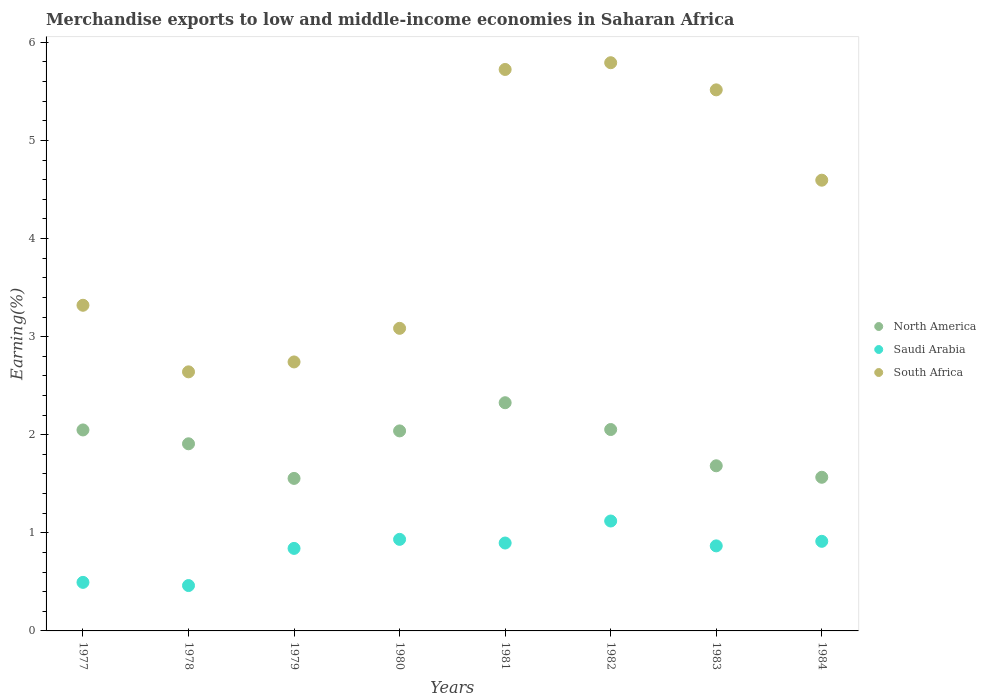How many different coloured dotlines are there?
Your answer should be compact. 3. What is the percentage of amount earned from merchandise exports in North America in 1980?
Give a very brief answer. 2.04. Across all years, what is the maximum percentage of amount earned from merchandise exports in South Africa?
Provide a succinct answer. 5.79. Across all years, what is the minimum percentage of amount earned from merchandise exports in Saudi Arabia?
Provide a succinct answer. 0.46. In which year was the percentage of amount earned from merchandise exports in Saudi Arabia maximum?
Give a very brief answer. 1982. In which year was the percentage of amount earned from merchandise exports in Saudi Arabia minimum?
Provide a succinct answer. 1978. What is the total percentage of amount earned from merchandise exports in South Africa in the graph?
Offer a terse response. 33.41. What is the difference between the percentage of amount earned from merchandise exports in South Africa in 1983 and that in 1984?
Provide a succinct answer. 0.92. What is the difference between the percentage of amount earned from merchandise exports in North America in 1981 and the percentage of amount earned from merchandise exports in South Africa in 1982?
Give a very brief answer. -3.47. What is the average percentage of amount earned from merchandise exports in South Africa per year?
Your response must be concise. 4.18. In the year 1978, what is the difference between the percentage of amount earned from merchandise exports in Saudi Arabia and percentage of amount earned from merchandise exports in North America?
Ensure brevity in your answer.  -1.45. What is the ratio of the percentage of amount earned from merchandise exports in South Africa in 1978 to that in 1981?
Offer a terse response. 0.46. Is the percentage of amount earned from merchandise exports in Saudi Arabia in 1982 less than that in 1983?
Your answer should be very brief. No. What is the difference between the highest and the second highest percentage of amount earned from merchandise exports in Saudi Arabia?
Your response must be concise. 0.19. What is the difference between the highest and the lowest percentage of amount earned from merchandise exports in North America?
Provide a short and direct response. 0.77. In how many years, is the percentage of amount earned from merchandise exports in South Africa greater than the average percentage of amount earned from merchandise exports in South Africa taken over all years?
Your answer should be very brief. 4. Is the percentage of amount earned from merchandise exports in South Africa strictly greater than the percentage of amount earned from merchandise exports in North America over the years?
Offer a terse response. Yes. Is the percentage of amount earned from merchandise exports in Saudi Arabia strictly less than the percentage of amount earned from merchandise exports in South Africa over the years?
Give a very brief answer. Yes. What is the difference between two consecutive major ticks on the Y-axis?
Provide a succinct answer. 1. Are the values on the major ticks of Y-axis written in scientific E-notation?
Ensure brevity in your answer.  No. Does the graph contain any zero values?
Keep it short and to the point. No. Where does the legend appear in the graph?
Offer a very short reply. Center right. What is the title of the graph?
Offer a very short reply. Merchandise exports to low and middle-income economies in Saharan Africa. Does "Brazil" appear as one of the legend labels in the graph?
Offer a terse response. No. What is the label or title of the X-axis?
Make the answer very short. Years. What is the label or title of the Y-axis?
Your answer should be compact. Earning(%). What is the Earning(%) of North America in 1977?
Your answer should be very brief. 2.05. What is the Earning(%) of Saudi Arabia in 1977?
Offer a terse response. 0.49. What is the Earning(%) in South Africa in 1977?
Offer a terse response. 3.32. What is the Earning(%) of North America in 1978?
Ensure brevity in your answer.  1.91. What is the Earning(%) of Saudi Arabia in 1978?
Provide a short and direct response. 0.46. What is the Earning(%) of South Africa in 1978?
Make the answer very short. 2.64. What is the Earning(%) in North America in 1979?
Your response must be concise. 1.55. What is the Earning(%) in Saudi Arabia in 1979?
Ensure brevity in your answer.  0.84. What is the Earning(%) of South Africa in 1979?
Your answer should be very brief. 2.74. What is the Earning(%) in North America in 1980?
Make the answer very short. 2.04. What is the Earning(%) in Saudi Arabia in 1980?
Provide a succinct answer. 0.93. What is the Earning(%) of South Africa in 1980?
Your answer should be compact. 3.08. What is the Earning(%) of North America in 1981?
Offer a terse response. 2.33. What is the Earning(%) of Saudi Arabia in 1981?
Provide a short and direct response. 0.9. What is the Earning(%) of South Africa in 1981?
Give a very brief answer. 5.72. What is the Earning(%) in North America in 1982?
Your response must be concise. 2.05. What is the Earning(%) in Saudi Arabia in 1982?
Your answer should be compact. 1.12. What is the Earning(%) of South Africa in 1982?
Your answer should be very brief. 5.79. What is the Earning(%) in North America in 1983?
Offer a very short reply. 1.68. What is the Earning(%) of Saudi Arabia in 1983?
Your answer should be very brief. 0.87. What is the Earning(%) of South Africa in 1983?
Make the answer very short. 5.52. What is the Earning(%) in North America in 1984?
Make the answer very short. 1.57. What is the Earning(%) in Saudi Arabia in 1984?
Offer a very short reply. 0.91. What is the Earning(%) in South Africa in 1984?
Ensure brevity in your answer.  4.59. Across all years, what is the maximum Earning(%) of North America?
Provide a succinct answer. 2.33. Across all years, what is the maximum Earning(%) in Saudi Arabia?
Offer a very short reply. 1.12. Across all years, what is the maximum Earning(%) in South Africa?
Offer a very short reply. 5.79. Across all years, what is the minimum Earning(%) in North America?
Your answer should be very brief. 1.55. Across all years, what is the minimum Earning(%) of Saudi Arabia?
Your answer should be very brief. 0.46. Across all years, what is the minimum Earning(%) of South Africa?
Your answer should be compact. 2.64. What is the total Earning(%) of North America in the graph?
Ensure brevity in your answer.  15.18. What is the total Earning(%) in Saudi Arabia in the graph?
Give a very brief answer. 6.53. What is the total Earning(%) of South Africa in the graph?
Provide a succinct answer. 33.41. What is the difference between the Earning(%) of North America in 1977 and that in 1978?
Your answer should be very brief. 0.14. What is the difference between the Earning(%) in Saudi Arabia in 1977 and that in 1978?
Offer a terse response. 0.03. What is the difference between the Earning(%) of South Africa in 1977 and that in 1978?
Ensure brevity in your answer.  0.68. What is the difference between the Earning(%) in North America in 1977 and that in 1979?
Give a very brief answer. 0.49. What is the difference between the Earning(%) in Saudi Arabia in 1977 and that in 1979?
Your answer should be very brief. -0.35. What is the difference between the Earning(%) in South Africa in 1977 and that in 1979?
Provide a short and direct response. 0.58. What is the difference between the Earning(%) of North America in 1977 and that in 1980?
Provide a short and direct response. 0.01. What is the difference between the Earning(%) of Saudi Arabia in 1977 and that in 1980?
Your answer should be very brief. -0.44. What is the difference between the Earning(%) in South Africa in 1977 and that in 1980?
Offer a very short reply. 0.24. What is the difference between the Earning(%) in North America in 1977 and that in 1981?
Your answer should be very brief. -0.28. What is the difference between the Earning(%) of Saudi Arabia in 1977 and that in 1981?
Give a very brief answer. -0.4. What is the difference between the Earning(%) of South Africa in 1977 and that in 1981?
Give a very brief answer. -2.4. What is the difference between the Earning(%) in North America in 1977 and that in 1982?
Provide a succinct answer. -0. What is the difference between the Earning(%) of Saudi Arabia in 1977 and that in 1982?
Provide a succinct answer. -0.63. What is the difference between the Earning(%) in South Africa in 1977 and that in 1982?
Your answer should be very brief. -2.47. What is the difference between the Earning(%) of North America in 1977 and that in 1983?
Your answer should be compact. 0.37. What is the difference between the Earning(%) of Saudi Arabia in 1977 and that in 1983?
Make the answer very short. -0.37. What is the difference between the Earning(%) of South Africa in 1977 and that in 1983?
Your answer should be compact. -2.2. What is the difference between the Earning(%) of North America in 1977 and that in 1984?
Ensure brevity in your answer.  0.48. What is the difference between the Earning(%) in Saudi Arabia in 1977 and that in 1984?
Your answer should be compact. -0.42. What is the difference between the Earning(%) of South Africa in 1977 and that in 1984?
Offer a very short reply. -1.28. What is the difference between the Earning(%) in North America in 1978 and that in 1979?
Provide a succinct answer. 0.35. What is the difference between the Earning(%) in Saudi Arabia in 1978 and that in 1979?
Your answer should be very brief. -0.38. What is the difference between the Earning(%) in South Africa in 1978 and that in 1979?
Keep it short and to the point. -0.1. What is the difference between the Earning(%) in North America in 1978 and that in 1980?
Offer a very short reply. -0.13. What is the difference between the Earning(%) of Saudi Arabia in 1978 and that in 1980?
Offer a very short reply. -0.47. What is the difference between the Earning(%) of South Africa in 1978 and that in 1980?
Your response must be concise. -0.44. What is the difference between the Earning(%) of North America in 1978 and that in 1981?
Your answer should be compact. -0.42. What is the difference between the Earning(%) in Saudi Arabia in 1978 and that in 1981?
Make the answer very short. -0.43. What is the difference between the Earning(%) in South Africa in 1978 and that in 1981?
Offer a terse response. -3.08. What is the difference between the Earning(%) in North America in 1978 and that in 1982?
Make the answer very short. -0.15. What is the difference between the Earning(%) in Saudi Arabia in 1978 and that in 1982?
Keep it short and to the point. -0.66. What is the difference between the Earning(%) of South Africa in 1978 and that in 1982?
Make the answer very short. -3.15. What is the difference between the Earning(%) in North America in 1978 and that in 1983?
Offer a very short reply. 0.22. What is the difference between the Earning(%) of Saudi Arabia in 1978 and that in 1983?
Provide a succinct answer. -0.4. What is the difference between the Earning(%) in South Africa in 1978 and that in 1983?
Give a very brief answer. -2.87. What is the difference between the Earning(%) of North America in 1978 and that in 1984?
Give a very brief answer. 0.34. What is the difference between the Earning(%) in Saudi Arabia in 1978 and that in 1984?
Offer a very short reply. -0.45. What is the difference between the Earning(%) in South Africa in 1978 and that in 1984?
Offer a terse response. -1.95. What is the difference between the Earning(%) in North America in 1979 and that in 1980?
Provide a short and direct response. -0.48. What is the difference between the Earning(%) of Saudi Arabia in 1979 and that in 1980?
Provide a short and direct response. -0.09. What is the difference between the Earning(%) of South Africa in 1979 and that in 1980?
Offer a terse response. -0.34. What is the difference between the Earning(%) of North America in 1979 and that in 1981?
Offer a very short reply. -0.77. What is the difference between the Earning(%) in Saudi Arabia in 1979 and that in 1981?
Give a very brief answer. -0.05. What is the difference between the Earning(%) in South Africa in 1979 and that in 1981?
Offer a terse response. -2.98. What is the difference between the Earning(%) in North America in 1979 and that in 1982?
Give a very brief answer. -0.5. What is the difference between the Earning(%) in Saudi Arabia in 1979 and that in 1982?
Make the answer very short. -0.28. What is the difference between the Earning(%) in South Africa in 1979 and that in 1982?
Your answer should be compact. -3.05. What is the difference between the Earning(%) of North America in 1979 and that in 1983?
Give a very brief answer. -0.13. What is the difference between the Earning(%) in Saudi Arabia in 1979 and that in 1983?
Offer a very short reply. -0.03. What is the difference between the Earning(%) of South Africa in 1979 and that in 1983?
Provide a succinct answer. -2.77. What is the difference between the Earning(%) in North America in 1979 and that in 1984?
Make the answer very short. -0.01. What is the difference between the Earning(%) of Saudi Arabia in 1979 and that in 1984?
Ensure brevity in your answer.  -0.07. What is the difference between the Earning(%) in South Africa in 1979 and that in 1984?
Make the answer very short. -1.85. What is the difference between the Earning(%) of North America in 1980 and that in 1981?
Provide a short and direct response. -0.29. What is the difference between the Earning(%) of Saudi Arabia in 1980 and that in 1981?
Make the answer very short. 0.04. What is the difference between the Earning(%) of South Africa in 1980 and that in 1981?
Your response must be concise. -2.64. What is the difference between the Earning(%) in North America in 1980 and that in 1982?
Offer a very short reply. -0.01. What is the difference between the Earning(%) in Saudi Arabia in 1980 and that in 1982?
Your answer should be very brief. -0.19. What is the difference between the Earning(%) of South Africa in 1980 and that in 1982?
Provide a short and direct response. -2.71. What is the difference between the Earning(%) of North America in 1980 and that in 1983?
Offer a terse response. 0.36. What is the difference between the Earning(%) of Saudi Arabia in 1980 and that in 1983?
Your answer should be compact. 0.07. What is the difference between the Earning(%) of South Africa in 1980 and that in 1983?
Give a very brief answer. -2.43. What is the difference between the Earning(%) in North America in 1980 and that in 1984?
Ensure brevity in your answer.  0.47. What is the difference between the Earning(%) of Saudi Arabia in 1980 and that in 1984?
Keep it short and to the point. 0.02. What is the difference between the Earning(%) of South Africa in 1980 and that in 1984?
Make the answer very short. -1.51. What is the difference between the Earning(%) in North America in 1981 and that in 1982?
Keep it short and to the point. 0.27. What is the difference between the Earning(%) of Saudi Arabia in 1981 and that in 1982?
Your response must be concise. -0.22. What is the difference between the Earning(%) in South Africa in 1981 and that in 1982?
Make the answer very short. -0.07. What is the difference between the Earning(%) of North America in 1981 and that in 1983?
Provide a short and direct response. 0.64. What is the difference between the Earning(%) of Saudi Arabia in 1981 and that in 1983?
Your response must be concise. 0.03. What is the difference between the Earning(%) of South Africa in 1981 and that in 1983?
Provide a succinct answer. 0.21. What is the difference between the Earning(%) of North America in 1981 and that in 1984?
Ensure brevity in your answer.  0.76. What is the difference between the Earning(%) of Saudi Arabia in 1981 and that in 1984?
Your answer should be very brief. -0.02. What is the difference between the Earning(%) in South Africa in 1981 and that in 1984?
Offer a very short reply. 1.13. What is the difference between the Earning(%) in North America in 1982 and that in 1983?
Your answer should be compact. 0.37. What is the difference between the Earning(%) in Saudi Arabia in 1982 and that in 1983?
Offer a very short reply. 0.25. What is the difference between the Earning(%) of South Africa in 1982 and that in 1983?
Offer a terse response. 0.28. What is the difference between the Earning(%) of North America in 1982 and that in 1984?
Give a very brief answer. 0.49. What is the difference between the Earning(%) of Saudi Arabia in 1982 and that in 1984?
Provide a short and direct response. 0.21. What is the difference between the Earning(%) in South Africa in 1982 and that in 1984?
Provide a succinct answer. 1.2. What is the difference between the Earning(%) of North America in 1983 and that in 1984?
Provide a succinct answer. 0.12. What is the difference between the Earning(%) of Saudi Arabia in 1983 and that in 1984?
Your response must be concise. -0.05. What is the difference between the Earning(%) in South Africa in 1983 and that in 1984?
Provide a short and direct response. 0.92. What is the difference between the Earning(%) of North America in 1977 and the Earning(%) of Saudi Arabia in 1978?
Give a very brief answer. 1.59. What is the difference between the Earning(%) of North America in 1977 and the Earning(%) of South Africa in 1978?
Provide a short and direct response. -0.59. What is the difference between the Earning(%) in Saudi Arabia in 1977 and the Earning(%) in South Africa in 1978?
Offer a very short reply. -2.15. What is the difference between the Earning(%) in North America in 1977 and the Earning(%) in Saudi Arabia in 1979?
Make the answer very short. 1.21. What is the difference between the Earning(%) of North America in 1977 and the Earning(%) of South Africa in 1979?
Your answer should be compact. -0.69. What is the difference between the Earning(%) of Saudi Arabia in 1977 and the Earning(%) of South Africa in 1979?
Offer a very short reply. -2.25. What is the difference between the Earning(%) of North America in 1977 and the Earning(%) of Saudi Arabia in 1980?
Give a very brief answer. 1.12. What is the difference between the Earning(%) in North America in 1977 and the Earning(%) in South Africa in 1980?
Provide a succinct answer. -1.04. What is the difference between the Earning(%) of Saudi Arabia in 1977 and the Earning(%) of South Africa in 1980?
Your answer should be compact. -2.59. What is the difference between the Earning(%) in North America in 1977 and the Earning(%) in Saudi Arabia in 1981?
Your response must be concise. 1.15. What is the difference between the Earning(%) in North America in 1977 and the Earning(%) in South Africa in 1981?
Ensure brevity in your answer.  -3.67. What is the difference between the Earning(%) in Saudi Arabia in 1977 and the Earning(%) in South Africa in 1981?
Offer a very short reply. -5.23. What is the difference between the Earning(%) of North America in 1977 and the Earning(%) of Saudi Arabia in 1982?
Provide a succinct answer. 0.93. What is the difference between the Earning(%) of North America in 1977 and the Earning(%) of South Africa in 1982?
Your answer should be very brief. -3.74. What is the difference between the Earning(%) of Saudi Arabia in 1977 and the Earning(%) of South Africa in 1982?
Your answer should be very brief. -5.3. What is the difference between the Earning(%) of North America in 1977 and the Earning(%) of Saudi Arabia in 1983?
Offer a terse response. 1.18. What is the difference between the Earning(%) in North America in 1977 and the Earning(%) in South Africa in 1983?
Your response must be concise. -3.47. What is the difference between the Earning(%) in Saudi Arabia in 1977 and the Earning(%) in South Africa in 1983?
Your answer should be very brief. -5.02. What is the difference between the Earning(%) of North America in 1977 and the Earning(%) of Saudi Arabia in 1984?
Offer a very short reply. 1.14. What is the difference between the Earning(%) in North America in 1977 and the Earning(%) in South Africa in 1984?
Make the answer very short. -2.55. What is the difference between the Earning(%) in Saudi Arabia in 1977 and the Earning(%) in South Africa in 1984?
Give a very brief answer. -4.1. What is the difference between the Earning(%) of North America in 1978 and the Earning(%) of Saudi Arabia in 1979?
Your answer should be very brief. 1.07. What is the difference between the Earning(%) of North America in 1978 and the Earning(%) of South Africa in 1979?
Give a very brief answer. -0.83. What is the difference between the Earning(%) in Saudi Arabia in 1978 and the Earning(%) in South Africa in 1979?
Keep it short and to the point. -2.28. What is the difference between the Earning(%) in North America in 1978 and the Earning(%) in Saudi Arabia in 1980?
Ensure brevity in your answer.  0.97. What is the difference between the Earning(%) of North America in 1978 and the Earning(%) of South Africa in 1980?
Provide a short and direct response. -1.18. What is the difference between the Earning(%) in Saudi Arabia in 1978 and the Earning(%) in South Africa in 1980?
Offer a very short reply. -2.62. What is the difference between the Earning(%) of North America in 1978 and the Earning(%) of Saudi Arabia in 1981?
Keep it short and to the point. 1.01. What is the difference between the Earning(%) in North America in 1978 and the Earning(%) in South Africa in 1981?
Your answer should be compact. -3.82. What is the difference between the Earning(%) in Saudi Arabia in 1978 and the Earning(%) in South Africa in 1981?
Ensure brevity in your answer.  -5.26. What is the difference between the Earning(%) of North America in 1978 and the Earning(%) of Saudi Arabia in 1982?
Your answer should be very brief. 0.79. What is the difference between the Earning(%) in North America in 1978 and the Earning(%) in South Africa in 1982?
Offer a terse response. -3.88. What is the difference between the Earning(%) of Saudi Arabia in 1978 and the Earning(%) of South Africa in 1982?
Provide a short and direct response. -5.33. What is the difference between the Earning(%) in North America in 1978 and the Earning(%) in Saudi Arabia in 1983?
Provide a succinct answer. 1.04. What is the difference between the Earning(%) in North America in 1978 and the Earning(%) in South Africa in 1983?
Keep it short and to the point. -3.61. What is the difference between the Earning(%) of Saudi Arabia in 1978 and the Earning(%) of South Africa in 1983?
Offer a very short reply. -5.05. What is the difference between the Earning(%) of North America in 1978 and the Earning(%) of Saudi Arabia in 1984?
Ensure brevity in your answer.  0.99. What is the difference between the Earning(%) of North America in 1978 and the Earning(%) of South Africa in 1984?
Provide a succinct answer. -2.69. What is the difference between the Earning(%) of Saudi Arabia in 1978 and the Earning(%) of South Africa in 1984?
Keep it short and to the point. -4.13. What is the difference between the Earning(%) in North America in 1979 and the Earning(%) in Saudi Arabia in 1980?
Give a very brief answer. 0.62. What is the difference between the Earning(%) in North America in 1979 and the Earning(%) in South Africa in 1980?
Provide a succinct answer. -1.53. What is the difference between the Earning(%) of Saudi Arabia in 1979 and the Earning(%) of South Africa in 1980?
Make the answer very short. -2.24. What is the difference between the Earning(%) of North America in 1979 and the Earning(%) of Saudi Arabia in 1981?
Make the answer very short. 0.66. What is the difference between the Earning(%) in North America in 1979 and the Earning(%) in South Africa in 1981?
Make the answer very short. -4.17. What is the difference between the Earning(%) of Saudi Arabia in 1979 and the Earning(%) of South Africa in 1981?
Offer a terse response. -4.88. What is the difference between the Earning(%) of North America in 1979 and the Earning(%) of Saudi Arabia in 1982?
Your answer should be very brief. 0.43. What is the difference between the Earning(%) in North America in 1979 and the Earning(%) in South Africa in 1982?
Your response must be concise. -4.24. What is the difference between the Earning(%) of Saudi Arabia in 1979 and the Earning(%) of South Africa in 1982?
Make the answer very short. -4.95. What is the difference between the Earning(%) of North America in 1979 and the Earning(%) of Saudi Arabia in 1983?
Make the answer very short. 0.69. What is the difference between the Earning(%) of North America in 1979 and the Earning(%) of South Africa in 1983?
Ensure brevity in your answer.  -3.96. What is the difference between the Earning(%) in Saudi Arabia in 1979 and the Earning(%) in South Africa in 1983?
Provide a short and direct response. -4.67. What is the difference between the Earning(%) in North America in 1979 and the Earning(%) in Saudi Arabia in 1984?
Offer a very short reply. 0.64. What is the difference between the Earning(%) in North America in 1979 and the Earning(%) in South Africa in 1984?
Make the answer very short. -3.04. What is the difference between the Earning(%) in Saudi Arabia in 1979 and the Earning(%) in South Africa in 1984?
Make the answer very short. -3.75. What is the difference between the Earning(%) in North America in 1980 and the Earning(%) in Saudi Arabia in 1981?
Keep it short and to the point. 1.14. What is the difference between the Earning(%) of North America in 1980 and the Earning(%) of South Africa in 1981?
Make the answer very short. -3.68. What is the difference between the Earning(%) in Saudi Arabia in 1980 and the Earning(%) in South Africa in 1981?
Offer a very short reply. -4.79. What is the difference between the Earning(%) of North America in 1980 and the Earning(%) of Saudi Arabia in 1982?
Your answer should be compact. 0.92. What is the difference between the Earning(%) in North America in 1980 and the Earning(%) in South Africa in 1982?
Your answer should be very brief. -3.75. What is the difference between the Earning(%) of Saudi Arabia in 1980 and the Earning(%) of South Africa in 1982?
Your answer should be compact. -4.86. What is the difference between the Earning(%) in North America in 1980 and the Earning(%) in Saudi Arabia in 1983?
Give a very brief answer. 1.17. What is the difference between the Earning(%) of North America in 1980 and the Earning(%) of South Africa in 1983?
Provide a succinct answer. -3.48. What is the difference between the Earning(%) of Saudi Arabia in 1980 and the Earning(%) of South Africa in 1983?
Your response must be concise. -4.58. What is the difference between the Earning(%) of North America in 1980 and the Earning(%) of Saudi Arabia in 1984?
Your answer should be compact. 1.13. What is the difference between the Earning(%) of North America in 1980 and the Earning(%) of South Africa in 1984?
Your answer should be very brief. -2.56. What is the difference between the Earning(%) of Saudi Arabia in 1980 and the Earning(%) of South Africa in 1984?
Your answer should be very brief. -3.66. What is the difference between the Earning(%) of North America in 1981 and the Earning(%) of Saudi Arabia in 1982?
Give a very brief answer. 1.21. What is the difference between the Earning(%) of North America in 1981 and the Earning(%) of South Africa in 1982?
Your answer should be very brief. -3.47. What is the difference between the Earning(%) of Saudi Arabia in 1981 and the Earning(%) of South Africa in 1982?
Your answer should be compact. -4.9. What is the difference between the Earning(%) of North America in 1981 and the Earning(%) of Saudi Arabia in 1983?
Your answer should be compact. 1.46. What is the difference between the Earning(%) in North America in 1981 and the Earning(%) in South Africa in 1983?
Provide a succinct answer. -3.19. What is the difference between the Earning(%) of Saudi Arabia in 1981 and the Earning(%) of South Africa in 1983?
Provide a short and direct response. -4.62. What is the difference between the Earning(%) in North America in 1981 and the Earning(%) in Saudi Arabia in 1984?
Your answer should be very brief. 1.41. What is the difference between the Earning(%) in North America in 1981 and the Earning(%) in South Africa in 1984?
Ensure brevity in your answer.  -2.27. What is the difference between the Earning(%) in Saudi Arabia in 1981 and the Earning(%) in South Africa in 1984?
Keep it short and to the point. -3.7. What is the difference between the Earning(%) in North America in 1982 and the Earning(%) in Saudi Arabia in 1983?
Offer a terse response. 1.19. What is the difference between the Earning(%) of North America in 1982 and the Earning(%) of South Africa in 1983?
Your answer should be very brief. -3.46. What is the difference between the Earning(%) of Saudi Arabia in 1982 and the Earning(%) of South Africa in 1983?
Your answer should be compact. -4.4. What is the difference between the Earning(%) of North America in 1982 and the Earning(%) of Saudi Arabia in 1984?
Your answer should be compact. 1.14. What is the difference between the Earning(%) in North America in 1982 and the Earning(%) in South Africa in 1984?
Give a very brief answer. -2.54. What is the difference between the Earning(%) in Saudi Arabia in 1982 and the Earning(%) in South Africa in 1984?
Keep it short and to the point. -3.47. What is the difference between the Earning(%) in North America in 1983 and the Earning(%) in Saudi Arabia in 1984?
Ensure brevity in your answer.  0.77. What is the difference between the Earning(%) in North America in 1983 and the Earning(%) in South Africa in 1984?
Your answer should be compact. -2.91. What is the difference between the Earning(%) in Saudi Arabia in 1983 and the Earning(%) in South Africa in 1984?
Your response must be concise. -3.73. What is the average Earning(%) in North America per year?
Keep it short and to the point. 1.9. What is the average Earning(%) of Saudi Arabia per year?
Make the answer very short. 0.82. What is the average Earning(%) in South Africa per year?
Offer a very short reply. 4.18. In the year 1977, what is the difference between the Earning(%) of North America and Earning(%) of Saudi Arabia?
Make the answer very short. 1.55. In the year 1977, what is the difference between the Earning(%) in North America and Earning(%) in South Africa?
Provide a short and direct response. -1.27. In the year 1977, what is the difference between the Earning(%) of Saudi Arabia and Earning(%) of South Africa?
Make the answer very short. -2.82. In the year 1978, what is the difference between the Earning(%) in North America and Earning(%) in Saudi Arabia?
Make the answer very short. 1.45. In the year 1978, what is the difference between the Earning(%) in North America and Earning(%) in South Africa?
Your answer should be compact. -0.73. In the year 1978, what is the difference between the Earning(%) in Saudi Arabia and Earning(%) in South Africa?
Give a very brief answer. -2.18. In the year 1979, what is the difference between the Earning(%) of North America and Earning(%) of Saudi Arabia?
Your response must be concise. 0.71. In the year 1979, what is the difference between the Earning(%) of North America and Earning(%) of South Africa?
Your answer should be very brief. -1.19. In the year 1979, what is the difference between the Earning(%) of Saudi Arabia and Earning(%) of South Africa?
Your answer should be very brief. -1.9. In the year 1980, what is the difference between the Earning(%) in North America and Earning(%) in Saudi Arabia?
Offer a terse response. 1.11. In the year 1980, what is the difference between the Earning(%) in North America and Earning(%) in South Africa?
Keep it short and to the point. -1.05. In the year 1980, what is the difference between the Earning(%) of Saudi Arabia and Earning(%) of South Africa?
Ensure brevity in your answer.  -2.15. In the year 1981, what is the difference between the Earning(%) of North America and Earning(%) of Saudi Arabia?
Your response must be concise. 1.43. In the year 1981, what is the difference between the Earning(%) of North America and Earning(%) of South Africa?
Provide a short and direct response. -3.4. In the year 1981, what is the difference between the Earning(%) in Saudi Arabia and Earning(%) in South Africa?
Make the answer very short. -4.83. In the year 1982, what is the difference between the Earning(%) in North America and Earning(%) in Saudi Arabia?
Make the answer very short. 0.93. In the year 1982, what is the difference between the Earning(%) of North America and Earning(%) of South Africa?
Give a very brief answer. -3.74. In the year 1982, what is the difference between the Earning(%) of Saudi Arabia and Earning(%) of South Africa?
Offer a terse response. -4.67. In the year 1983, what is the difference between the Earning(%) of North America and Earning(%) of Saudi Arabia?
Your answer should be compact. 0.82. In the year 1983, what is the difference between the Earning(%) of North America and Earning(%) of South Africa?
Provide a short and direct response. -3.83. In the year 1983, what is the difference between the Earning(%) in Saudi Arabia and Earning(%) in South Africa?
Provide a short and direct response. -4.65. In the year 1984, what is the difference between the Earning(%) of North America and Earning(%) of Saudi Arabia?
Keep it short and to the point. 0.65. In the year 1984, what is the difference between the Earning(%) in North America and Earning(%) in South Africa?
Your response must be concise. -3.03. In the year 1984, what is the difference between the Earning(%) of Saudi Arabia and Earning(%) of South Africa?
Your response must be concise. -3.68. What is the ratio of the Earning(%) in North America in 1977 to that in 1978?
Provide a succinct answer. 1.07. What is the ratio of the Earning(%) in Saudi Arabia in 1977 to that in 1978?
Make the answer very short. 1.07. What is the ratio of the Earning(%) of South Africa in 1977 to that in 1978?
Make the answer very short. 1.26. What is the ratio of the Earning(%) in North America in 1977 to that in 1979?
Offer a terse response. 1.32. What is the ratio of the Earning(%) of Saudi Arabia in 1977 to that in 1979?
Provide a succinct answer. 0.59. What is the ratio of the Earning(%) in South Africa in 1977 to that in 1979?
Your answer should be very brief. 1.21. What is the ratio of the Earning(%) of North America in 1977 to that in 1980?
Provide a short and direct response. 1. What is the ratio of the Earning(%) in Saudi Arabia in 1977 to that in 1980?
Offer a very short reply. 0.53. What is the ratio of the Earning(%) in South Africa in 1977 to that in 1980?
Provide a succinct answer. 1.08. What is the ratio of the Earning(%) of North America in 1977 to that in 1981?
Give a very brief answer. 0.88. What is the ratio of the Earning(%) in Saudi Arabia in 1977 to that in 1981?
Give a very brief answer. 0.55. What is the ratio of the Earning(%) of South Africa in 1977 to that in 1981?
Your answer should be compact. 0.58. What is the ratio of the Earning(%) of Saudi Arabia in 1977 to that in 1982?
Keep it short and to the point. 0.44. What is the ratio of the Earning(%) in South Africa in 1977 to that in 1982?
Offer a terse response. 0.57. What is the ratio of the Earning(%) of North America in 1977 to that in 1983?
Give a very brief answer. 1.22. What is the ratio of the Earning(%) in Saudi Arabia in 1977 to that in 1983?
Provide a succinct answer. 0.57. What is the ratio of the Earning(%) in South Africa in 1977 to that in 1983?
Offer a very short reply. 0.6. What is the ratio of the Earning(%) of North America in 1977 to that in 1984?
Offer a terse response. 1.31. What is the ratio of the Earning(%) in Saudi Arabia in 1977 to that in 1984?
Offer a very short reply. 0.54. What is the ratio of the Earning(%) in South Africa in 1977 to that in 1984?
Provide a short and direct response. 0.72. What is the ratio of the Earning(%) in North America in 1978 to that in 1979?
Provide a short and direct response. 1.23. What is the ratio of the Earning(%) of Saudi Arabia in 1978 to that in 1979?
Provide a short and direct response. 0.55. What is the ratio of the Earning(%) in South Africa in 1978 to that in 1979?
Your answer should be very brief. 0.96. What is the ratio of the Earning(%) of North America in 1978 to that in 1980?
Provide a short and direct response. 0.94. What is the ratio of the Earning(%) of Saudi Arabia in 1978 to that in 1980?
Make the answer very short. 0.5. What is the ratio of the Earning(%) of South Africa in 1978 to that in 1980?
Provide a short and direct response. 0.86. What is the ratio of the Earning(%) in North America in 1978 to that in 1981?
Ensure brevity in your answer.  0.82. What is the ratio of the Earning(%) of Saudi Arabia in 1978 to that in 1981?
Your answer should be very brief. 0.52. What is the ratio of the Earning(%) in South Africa in 1978 to that in 1981?
Provide a succinct answer. 0.46. What is the ratio of the Earning(%) of North America in 1978 to that in 1982?
Give a very brief answer. 0.93. What is the ratio of the Earning(%) in Saudi Arabia in 1978 to that in 1982?
Offer a terse response. 0.41. What is the ratio of the Earning(%) of South Africa in 1978 to that in 1982?
Provide a succinct answer. 0.46. What is the ratio of the Earning(%) of North America in 1978 to that in 1983?
Your answer should be very brief. 1.13. What is the ratio of the Earning(%) of Saudi Arabia in 1978 to that in 1983?
Your answer should be compact. 0.53. What is the ratio of the Earning(%) of South Africa in 1978 to that in 1983?
Give a very brief answer. 0.48. What is the ratio of the Earning(%) in North America in 1978 to that in 1984?
Your answer should be very brief. 1.22. What is the ratio of the Earning(%) of Saudi Arabia in 1978 to that in 1984?
Provide a short and direct response. 0.51. What is the ratio of the Earning(%) in South Africa in 1978 to that in 1984?
Offer a terse response. 0.57. What is the ratio of the Earning(%) of North America in 1979 to that in 1980?
Provide a succinct answer. 0.76. What is the ratio of the Earning(%) of Saudi Arabia in 1979 to that in 1980?
Keep it short and to the point. 0.9. What is the ratio of the Earning(%) in North America in 1979 to that in 1981?
Give a very brief answer. 0.67. What is the ratio of the Earning(%) of Saudi Arabia in 1979 to that in 1981?
Your answer should be very brief. 0.94. What is the ratio of the Earning(%) in South Africa in 1979 to that in 1981?
Your answer should be compact. 0.48. What is the ratio of the Earning(%) in North America in 1979 to that in 1982?
Your answer should be compact. 0.76. What is the ratio of the Earning(%) of Saudi Arabia in 1979 to that in 1982?
Ensure brevity in your answer.  0.75. What is the ratio of the Earning(%) of South Africa in 1979 to that in 1982?
Provide a succinct answer. 0.47. What is the ratio of the Earning(%) of North America in 1979 to that in 1983?
Make the answer very short. 0.92. What is the ratio of the Earning(%) of Saudi Arabia in 1979 to that in 1983?
Provide a short and direct response. 0.97. What is the ratio of the Earning(%) in South Africa in 1979 to that in 1983?
Offer a terse response. 0.5. What is the ratio of the Earning(%) of Saudi Arabia in 1979 to that in 1984?
Ensure brevity in your answer.  0.92. What is the ratio of the Earning(%) of South Africa in 1979 to that in 1984?
Keep it short and to the point. 0.6. What is the ratio of the Earning(%) of North America in 1980 to that in 1981?
Keep it short and to the point. 0.88. What is the ratio of the Earning(%) of Saudi Arabia in 1980 to that in 1981?
Give a very brief answer. 1.04. What is the ratio of the Earning(%) in South Africa in 1980 to that in 1981?
Offer a very short reply. 0.54. What is the ratio of the Earning(%) of North America in 1980 to that in 1982?
Your response must be concise. 0.99. What is the ratio of the Earning(%) of Saudi Arabia in 1980 to that in 1982?
Provide a succinct answer. 0.83. What is the ratio of the Earning(%) in South Africa in 1980 to that in 1982?
Your answer should be compact. 0.53. What is the ratio of the Earning(%) in North America in 1980 to that in 1983?
Offer a very short reply. 1.21. What is the ratio of the Earning(%) in Saudi Arabia in 1980 to that in 1983?
Provide a short and direct response. 1.08. What is the ratio of the Earning(%) of South Africa in 1980 to that in 1983?
Your answer should be very brief. 0.56. What is the ratio of the Earning(%) of North America in 1980 to that in 1984?
Your answer should be very brief. 1.3. What is the ratio of the Earning(%) in Saudi Arabia in 1980 to that in 1984?
Provide a short and direct response. 1.02. What is the ratio of the Earning(%) of South Africa in 1980 to that in 1984?
Your response must be concise. 0.67. What is the ratio of the Earning(%) in North America in 1981 to that in 1982?
Provide a short and direct response. 1.13. What is the ratio of the Earning(%) in Saudi Arabia in 1981 to that in 1982?
Your answer should be compact. 0.8. What is the ratio of the Earning(%) of North America in 1981 to that in 1983?
Provide a short and direct response. 1.38. What is the ratio of the Earning(%) of Saudi Arabia in 1981 to that in 1983?
Your response must be concise. 1.03. What is the ratio of the Earning(%) of South Africa in 1981 to that in 1983?
Offer a very short reply. 1.04. What is the ratio of the Earning(%) of North America in 1981 to that in 1984?
Provide a succinct answer. 1.49. What is the ratio of the Earning(%) of Saudi Arabia in 1981 to that in 1984?
Ensure brevity in your answer.  0.98. What is the ratio of the Earning(%) in South Africa in 1981 to that in 1984?
Give a very brief answer. 1.25. What is the ratio of the Earning(%) of North America in 1982 to that in 1983?
Ensure brevity in your answer.  1.22. What is the ratio of the Earning(%) in Saudi Arabia in 1982 to that in 1983?
Provide a short and direct response. 1.29. What is the ratio of the Earning(%) of South Africa in 1982 to that in 1983?
Provide a short and direct response. 1.05. What is the ratio of the Earning(%) in North America in 1982 to that in 1984?
Provide a short and direct response. 1.31. What is the ratio of the Earning(%) of Saudi Arabia in 1982 to that in 1984?
Ensure brevity in your answer.  1.23. What is the ratio of the Earning(%) in South Africa in 1982 to that in 1984?
Make the answer very short. 1.26. What is the ratio of the Earning(%) in North America in 1983 to that in 1984?
Offer a very short reply. 1.07. What is the ratio of the Earning(%) of Saudi Arabia in 1983 to that in 1984?
Your answer should be compact. 0.95. What is the ratio of the Earning(%) of South Africa in 1983 to that in 1984?
Give a very brief answer. 1.2. What is the difference between the highest and the second highest Earning(%) of North America?
Give a very brief answer. 0.27. What is the difference between the highest and the second highest Earning(%) in Saudi Arabia?
Provide a short and direct response. 0.19. What is the difference between the highest and the second highest Earning(%) of South Africa?
Make the answer very short. 0.07. What is the difference between the highest and the lowest Earning(%) in North America?
Ensure brevity in your answer.  0.77. What is the difference between the highest and the lowest Earning(%) in Saudi Arabia?
Your answer should be very brief. 0.66. What is the difference between the highest and the lowest Earning(%) of South Africa?
Your answer should be compact. 3.15. 